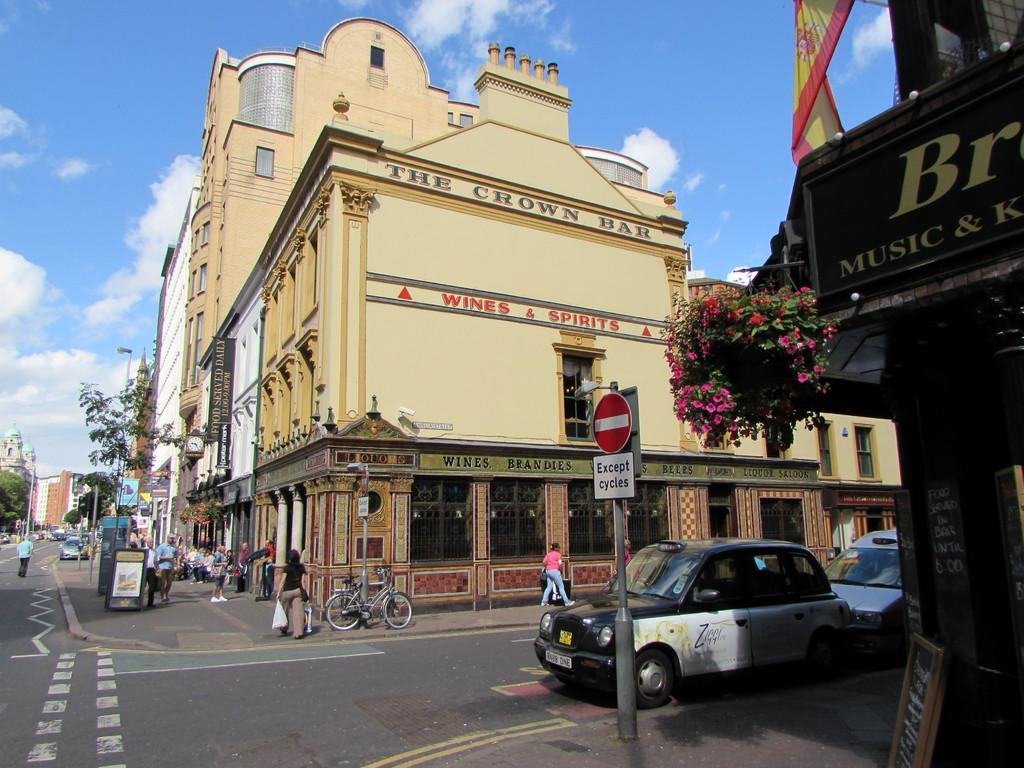<image>
Present a compact description of the photo's key features. A tan building says Wines & Spirits and pedestrians are walking by. 